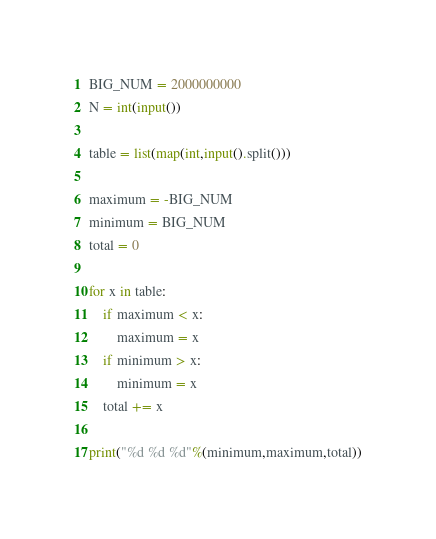Convert code to text. <code><loc_0><loc_0><loc_500><loc_500><_Python_>BIG_NUM = 2000000000
N = int(input())

table = list(map(int,input().split()))

maximum = -BIG_NUM
minimum = BIG_NUM
total = 0

for x in table:
    if maximum < x:
        maximum = x
    if minimum > x:
        minimum = x
    total += x

print("%d %d %d"%(minimum,maximum,total))
</code> 